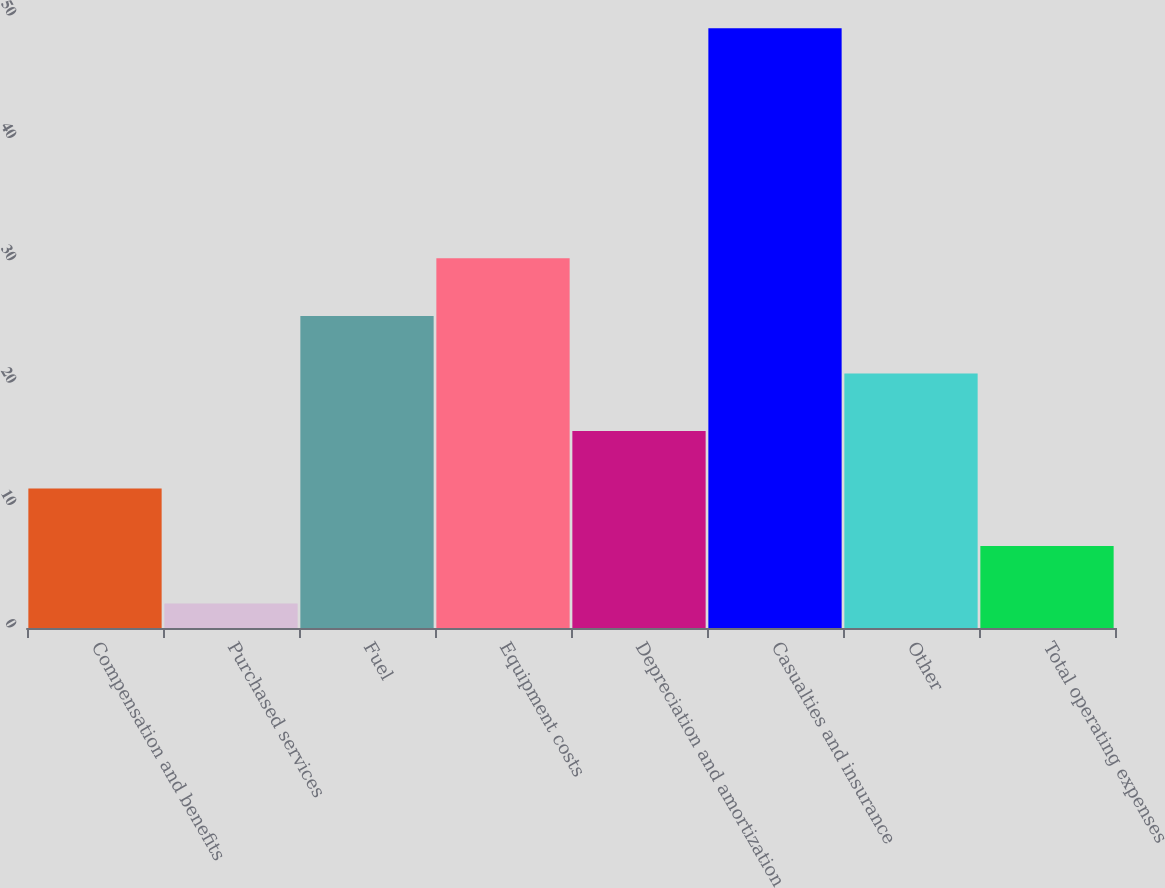Convert chart to OTSL. <chart><loc_0><loc_0><loc_500><loc_500><bar_chart><fcel>Compensation and benefits<fcel>Purchased services<fcel>Fuel<fcel>Equipment costs<fcel>Depreciation and amortization<fcel>Casualties and insurance<fcel>Other<fcel>Total operating expenses<nl><fcel>11.4<fcel>2<fcel>25.5<fcel>30.2<fcel>16.1<fcel>49<fcel>20.8<fcel>6.7<nl></chart> 